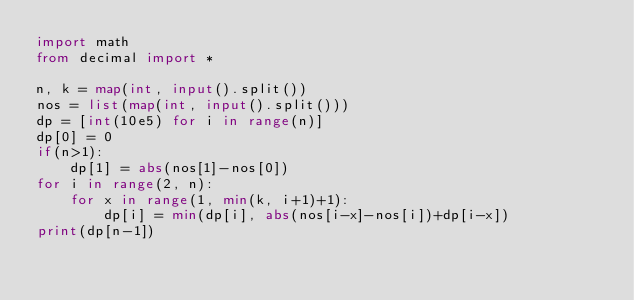Convert code to text. <code><loc_0><loc_0><loc_500><loc_500><_Python_>import math
from decimal import *

n, k = map(int, input().split())
nos = list(map(int, input().split()))
dp = [int(10e5) for i in range(n)]
dp[0] = 0
if(n>1):
    dp[1] = abs(nos[1]-nos[0])
for i in range(2, n):
    for x in range(1, min(k, i+1)+1):
        dp[i] = min(dp[i], abs(nos[i-x]-nos[i])+dp[i-x])
print(dp[n-1])
</code> 